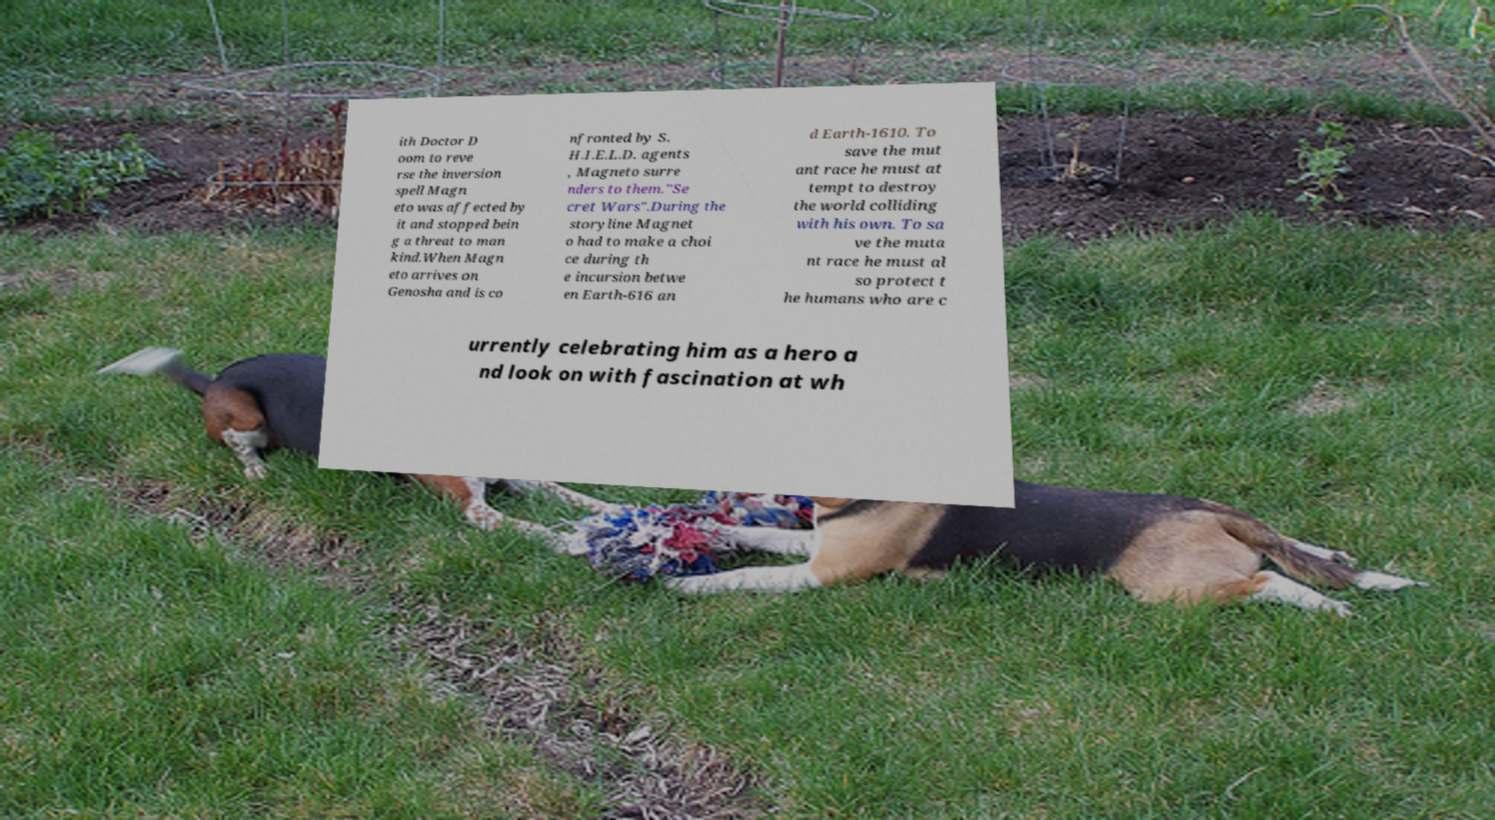Please read and relay the text visible in this image. What does it say? ith Doctor D oom to reve rse the inversion spell Magn eto was affected by it and stopped bein g a threat to man kind.When Magn eto arrives on Genosha and is co nfronted by S. H.I.E.L.D. agents , Magneto surre nders to them."Se cret Wars".During the storyline Magnet o had to make a choi ce during th e incursion betwe en Earth-616 an d Earth-1610. To save the mut ant race he must at tempt to destroy the world colliding with his own. To sa ve the muta nt race he must al so protect t he humans who are c urrently celebrating him as a hero a nd look on with fascination at wh 